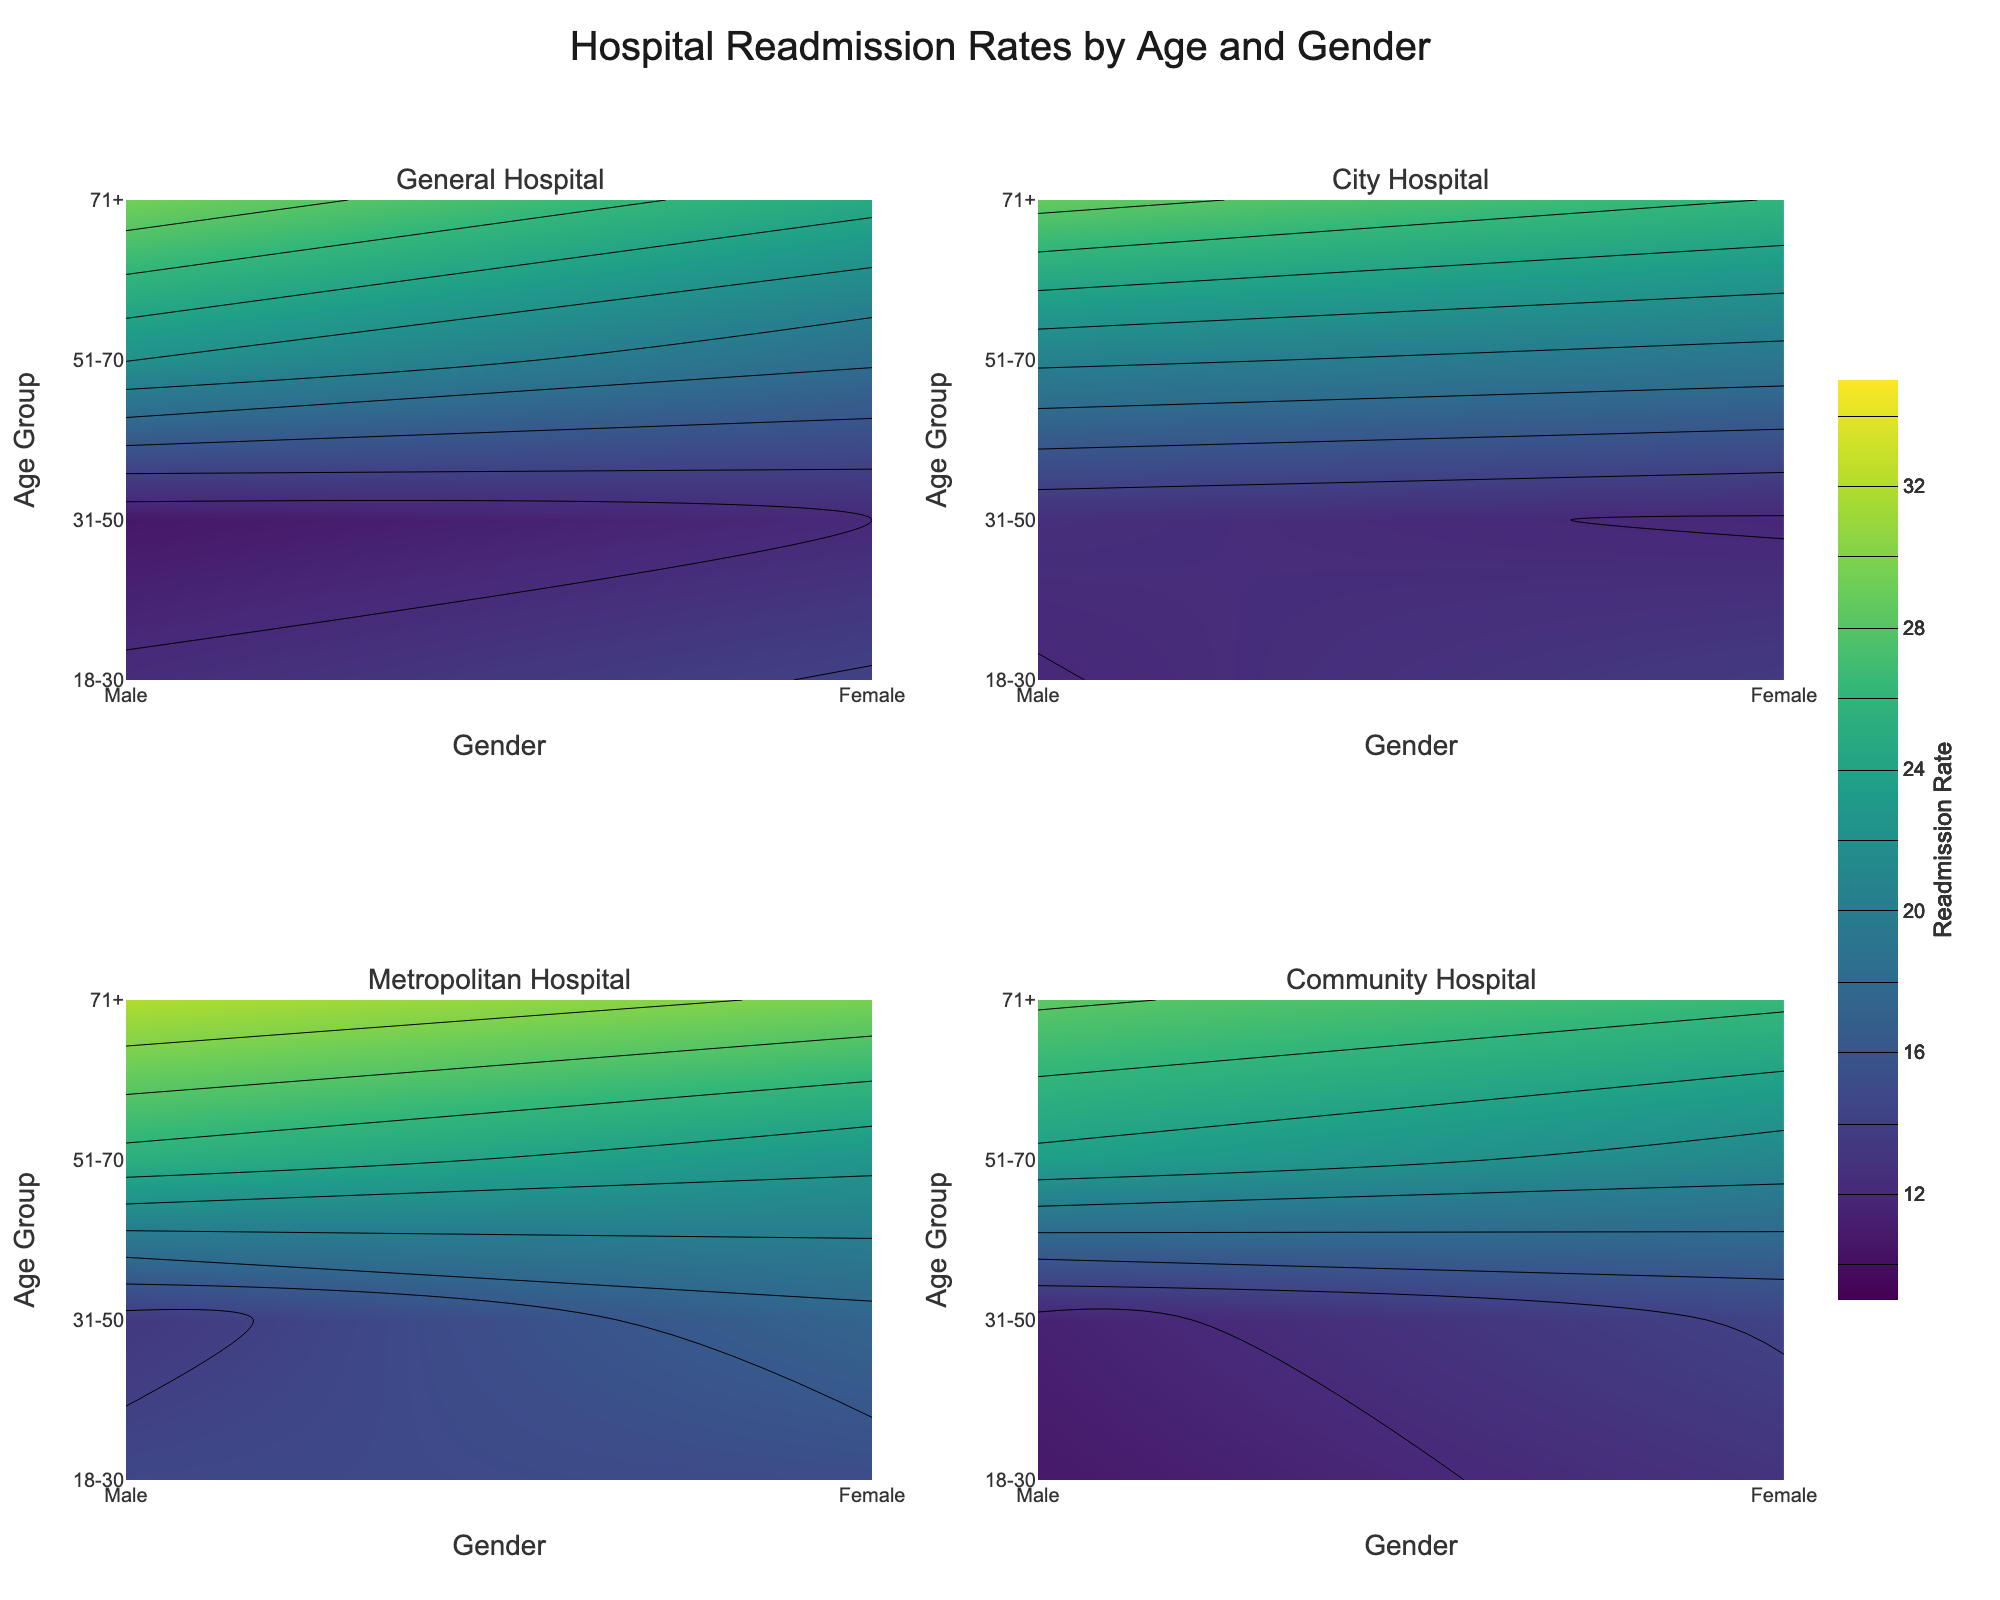What is the main title of the figure? The main title is located at the top center of the figure and is prominent due to its larger font size.
Answer: Hospital Readmission Rates by Age and Gender What age group has the highest readmission rate in General Hospital? By examining the contour plot for General Hospital, locate the age group with the highest value on the color scale. The darkest regions indicate the highest readmission rates.
Answer: 71+ Which hospital shows the highest readmission rate for females aged 31-50? Look across the four subplot contour plots for the specific cell corresponding to females aged 31-50. Choose the cell with the highest color intensity.
Answer: Metropolitan Hospital In which gender and age group does City Hospital have the lowest readmission rate? Inspect the contour plot for City Hospital and find the lowest value on the color scale. Identify the corresponding gender and age group from the axes labels.
Answer: Male, 18-30 Compare the readmission rates for males aged 51-70 in Community Hospital and Metropolitan Hospital. Which hospital has a higher rate? Compare the values at the intersection of 'Male' and '51-70' for both Community Hospital and Metropolitan Hospital plots.
Answer: Metropolitan Hospital What is the difference in readmission rates for females aged 71+ between General Hospital and Community Hospital? Locate the value for females aged 71+ in both General Hospital and Community Hospital plots and subtract one from the other to find the difference.
Answer: 1.7 Which hospital has a more uniform distribution of readmission rates across all age groups and genders? Examine the contour plots and identify the hospital with the least variation in color intensity, indicating a more uniform distribution of readmission rates.
Answer: City Hospital What is the average readmission rate for all age groups and genders in General Hospital? Sum the readmission rates for all cells in the General Hospital plot and divide by the total number of cells (8 in this case).
Answer: 17.34 Observe the color bar in the figure. What is the range of readmission rates? The color bar beside one of the contour plots indicates the minimum and maximum readmission rates.
Answer: 10 to 35 Identify which age group generally shows higher readmission rates across all hospitals. Compare the shading intensities across all plots to determine which age group consistently appears darker, indicating higher readmission rates.
Answer: 71+ 